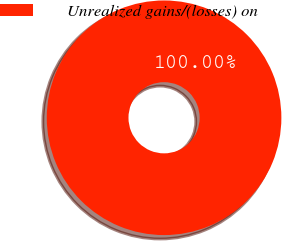Convert chart to OTSL. <chart><loc_0><loc_0><loc_500><loc_500><pie_chart><fcel>Unrealized gains/(losses) on<nl><fcel>100.0%<nl></chart> 